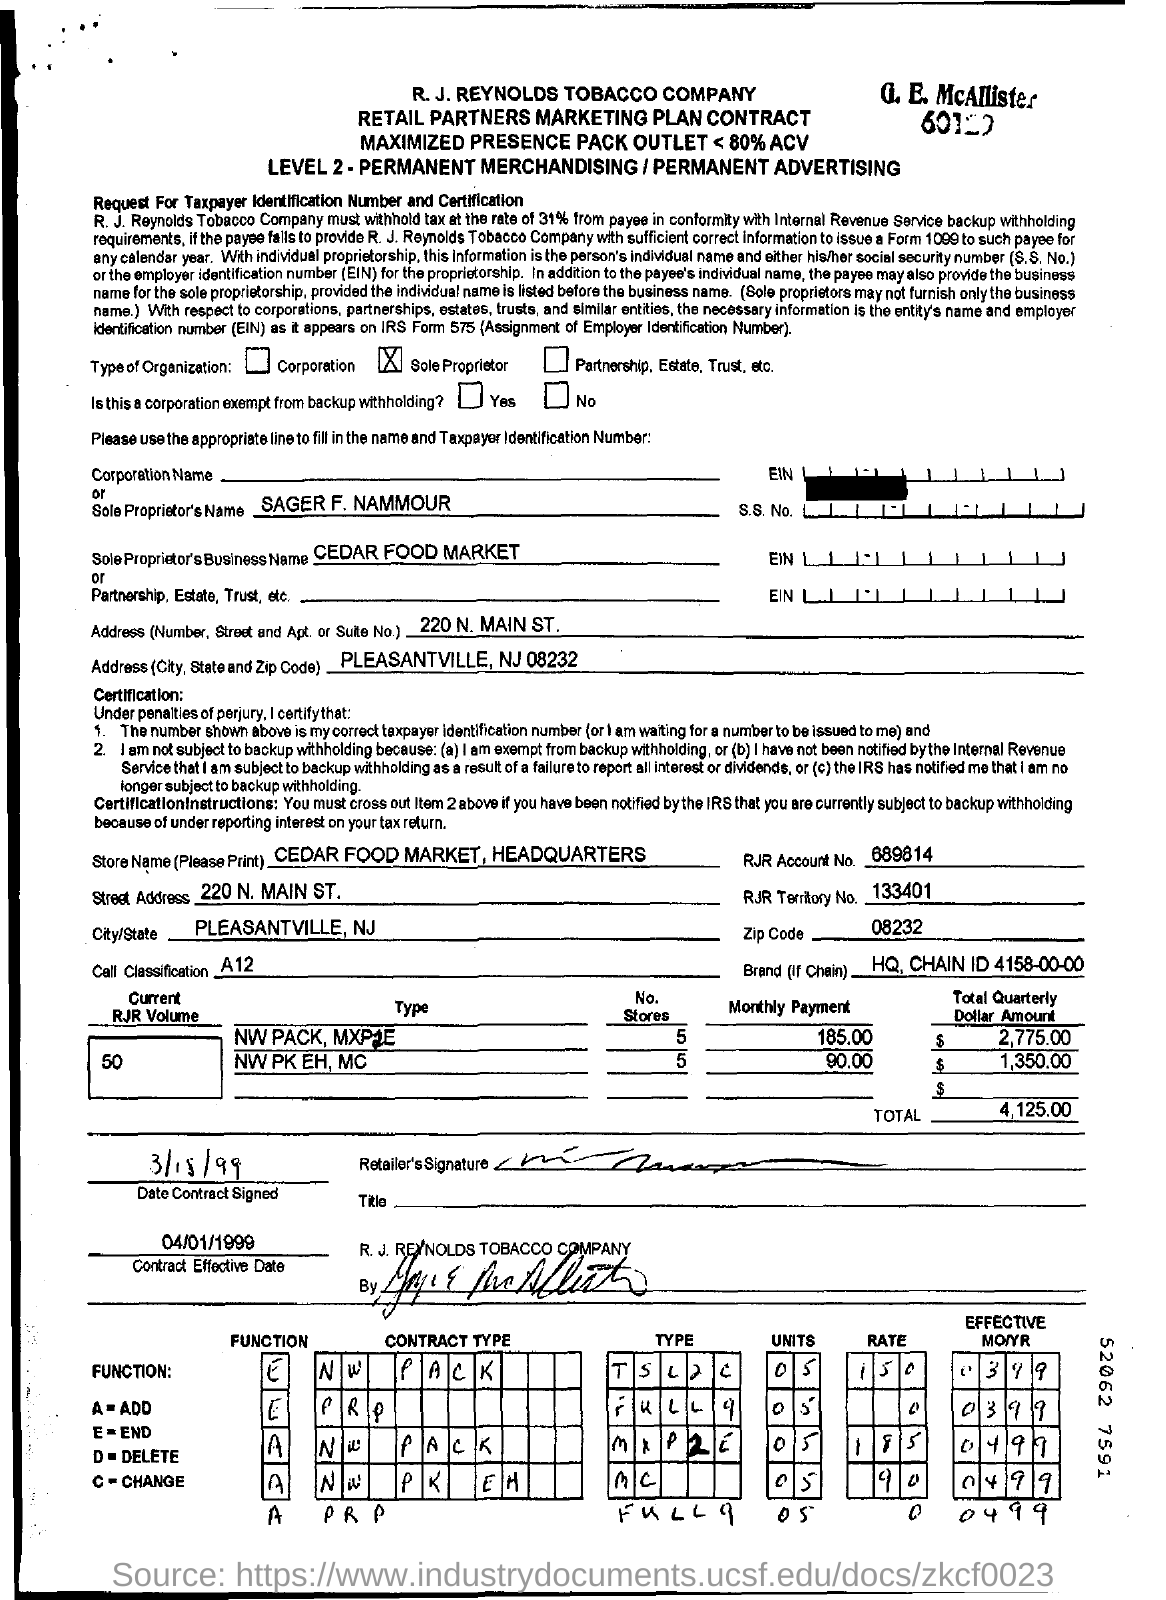Highlight a few significant elements in this photo. The contract's effective date is mentioned as 04/01/1999. The total amount mentioned in the contract is 4,125.00. The proprietor's business name is Cedar Food Market. 